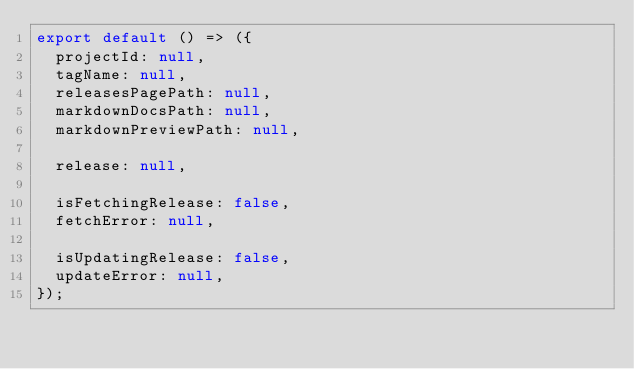<code> <loc_0><loc_0><loc_500><loc_500><_JavaScript_>export default () => ({
  projectId: null,
  tagName: null,
  releasesPagePath: null,
  markdownDocsPath: null,
  markdownPreviewPath: null,

  release: null,

  isFetchingRelease: false,
  fetchError: null,

  isUpdatingRelease: false,
  updateError: null,
});
</code> 